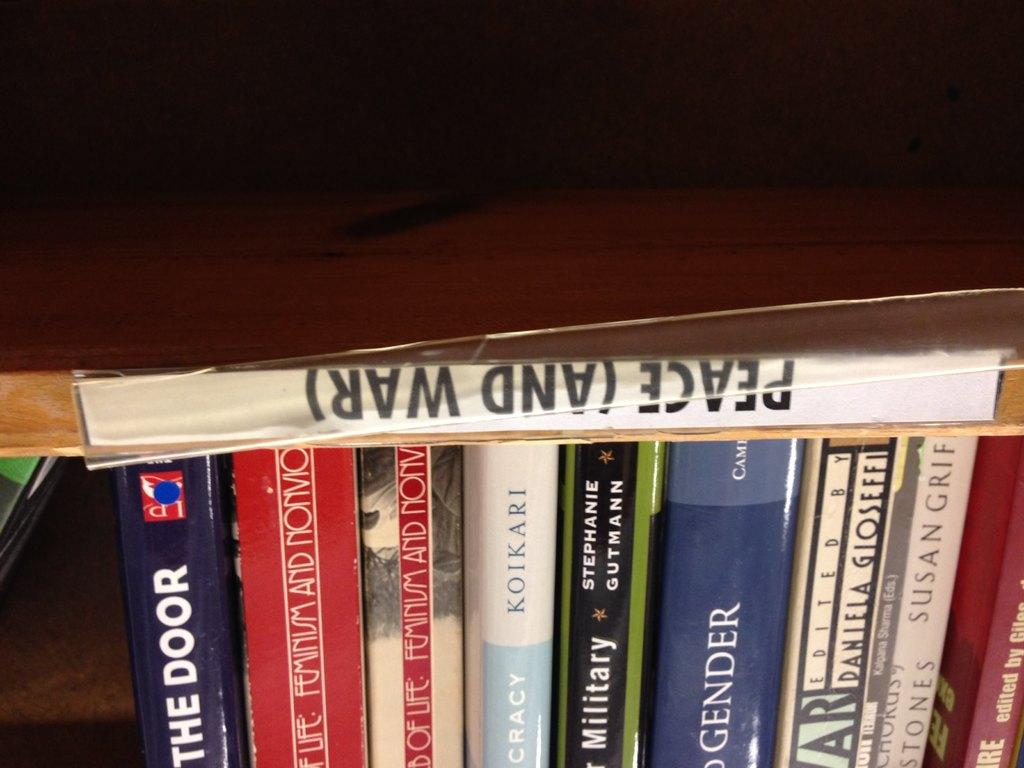<image>
Render a clear and concise summary of the photo. Peace and war book and the door book also. 